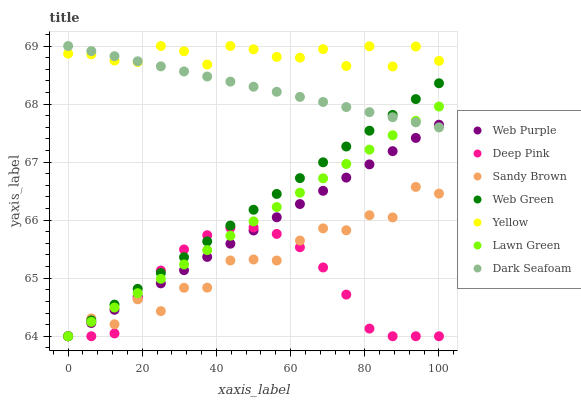Does Deep Pink have the minimum area under the curve?
Answer yes or no. Yes. Does Yellow have the maximum area under the curve?
Answer yes or no. Yes. Does Dark Seafoam have the minimum area under the curve?
Answer yes or no. No. Does Dark Seafoam have the maximum area under the curve?
Answer yes or no. No. Is Lawn Green the smoothest?
Answer yes or no. Yes. Is Sandy Brown the roughest?
Answer yes or no. Yes. Is Deep Pink the smoothest?
Answer yes or no. No. Is Deep Pink the roughest?
Answer yes or no. No. Does Lawn Green have the lowest value?
Answer yes or no. Yes. Does Dark Seafoam have the lowest value?
Answer yes or no. No. Does Yellow have the highest value?
Answer yes or no. Yes. Does Deep Pink have the highest value?
Answer yes or no. No. Is Sandy Brown less than Dark Seafoam?
Answer yes or no. Yes. Is Yellow greater than Sandy Brown?
Answer yes or no. Yes. Does Web Purple intersect Dark Seafoam?
Answer yes or no. Yes. Is Web Purple less than Dark Seafoam?
Answer yes or no. No. Is Web Purple greater than Dark Seafoam?
Answer yes or no. No. Does Sandy Brown intersect Dark Seafoam?
Answer yes or no. No. 